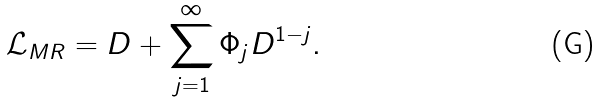Convert formula to latex. <formula><loc_0><loc_0><loc_500><loc_500>\mathcal { L } _ { M R } = D + \sum _ { j = 1 } ^ { \infty } \Phi _ { j } D ^ { 1 - j } .</formula> 